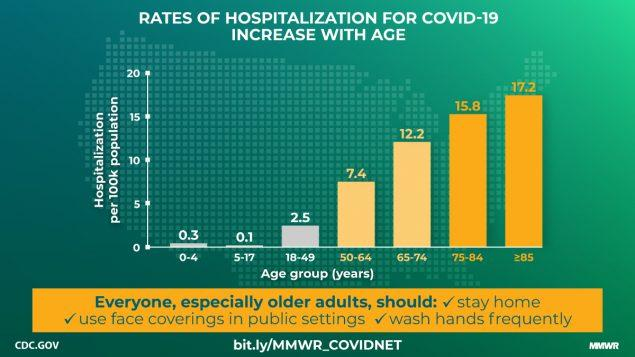Outline some significant characteristics in this image. The hospitalization rate for those aged 75-84 is the second highest among all age groups. The hospitalization rate has been lowest for the age group of 5-17. In the age group above 75 years old, there is a total count of 33 people per 100,000 hospitalized. 